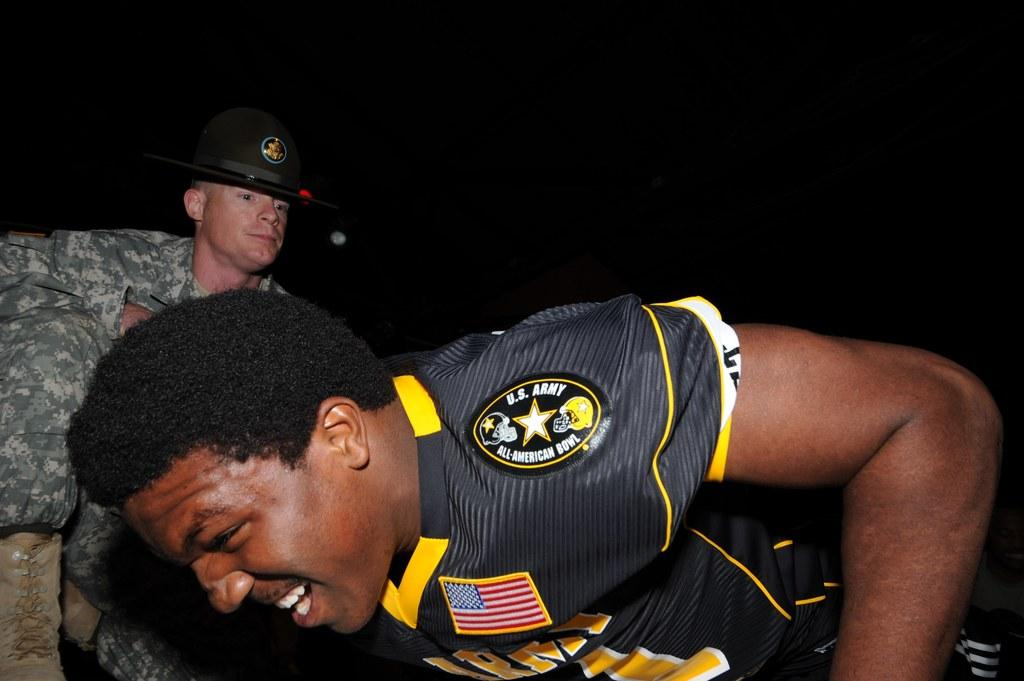<image>
Summarize the visual content of the image. a man with a grimace on his face with a U.S Navy logo on it 